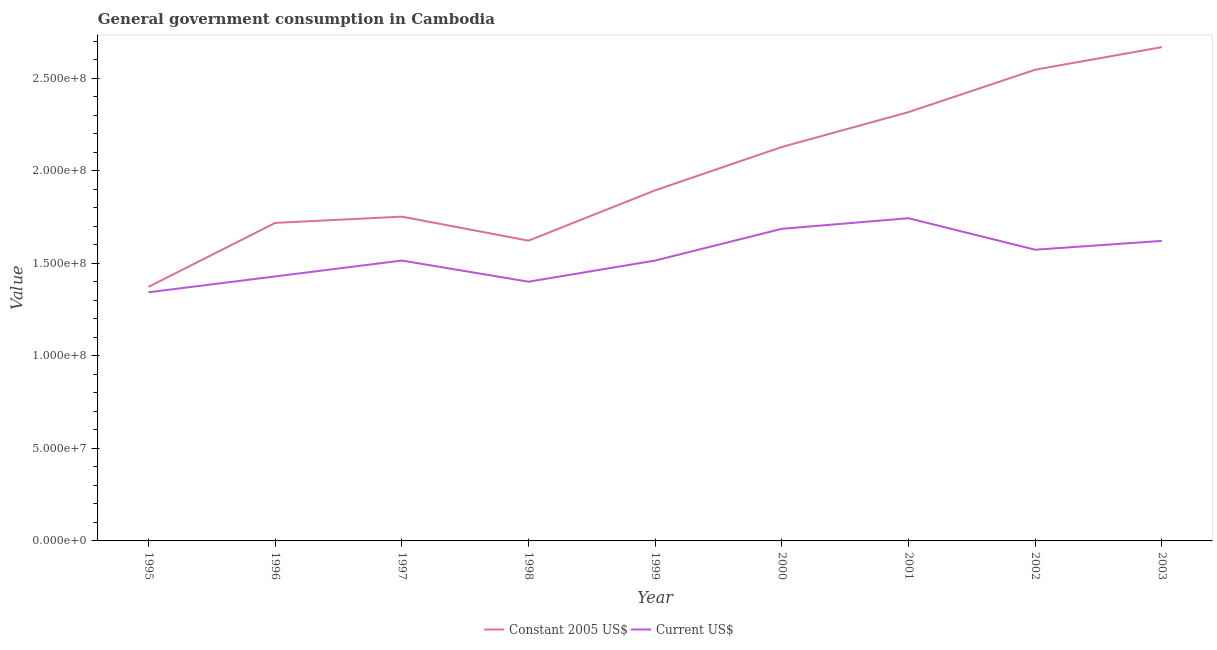Does the line corresponding to value consumed in current us$ intersect with the line corresponding to value consumed in constant 2005 us$?
Keep it short and to the point. No. Is the number of lines equal to the number of legend labels?
Your answer should be compact. Yes. What is the value consumed in current us$ in 2000?
Provide a short and direct response. 1.69e+08. Across all years, what is the maximum value consumed in current us$?
Give a very brief answer. 1.74e+08. Across all years, what is the minimum value consumed in current us$?
Offer a very short reply. 1.34e+08. What is the total value consumed in constant 2005 us$ in the graph?
Make the answer very short. 1.80e+09. What is the difference between the value consumed in current us$ in 2000 and that in 2003?
Make the answer very short. 6.53e+06. What is the difference between the value consumed in constant 2005 us$ in 1998 and the value consumed in current us$ in 2001?
Provide a succinct answer. -1.21e+07. What is the average value consumed in constant 2005 us$ per year?
Your response must be concise. 2.00e+08. In the year 1995, what is the difference between the value consumed in constant 2005 us$ and value consumed in current us$?
Offer a very short reply. 2.94e+06. In how many years, is the value consumed in current us$ greater than 250000000?
Your answer should be compact. 0. What is the ratio of the value consumed in constant 2005 us$ in 1996 to that in 2003?
Keep it short and to the point. 0.64. What is the difference between the highest and the second highest value consumed in constant 2005 us$?
Your answer should be compact. 1.22e+07. What is the difference between the highest and the lowest value consumed in constant 2005 us$?
Your answer should be compact. 1.29e+08. Is the value consumed in current us$ strictly greater than the value consumed in constant 2005 us$ over the years?
Offer a terse response. No. How many lines are there?
Provide a succinct answer. 2. How many years are there in the graph?
Ensure brevity in your answer.  9. Are the values on the major ticks of Y-axis written in scientific E-notation?
Ensure brevity in your answer.  Yes. Does the graph contain any zero values?
Keep it short and to the point. No. What is the title of the graph?
Offer a very short reply. General government consumption in Cambodia. What is the label or title of the Y-axis?
Make the answer very short. Value. What is the Value in Constant 2005 US$ in 1995?
Your answer should be compact. 1.37e+08. What is the Value in Current US$ in 1995?
Keep it short and to the point. 1.34e+08. What is the Value of Constant 2005 US$ in 1996?
Your response must be concise. 1.72e+08. What is the Value in Current US$ in 1996?
Your answer should be compact. 1.43e+08. What is the Value of Constant 2005 US$ in 1997?
Give a very brief answer. 1.75e+08. What is the Value of Current US$ in 1997?
Your response must be concise. 1.51e+08. What is the Value in Constant 2005 US$ in 1998?
Your response must be concise. 1.62e+08. What is the Value of Current US$ in 1998?
Ensure brevity in your answer.  1.40e+08. What is the Value in Constant 2005 US$ in 1999?
Offer a very short reply. 1.89e+08. What is the Value in Current US$ in 1999?
Ensure brevity in your answer.  1.51e+08. What is the Value of Constant 2005 US$ in 2000?
Offer a very short reply. 2.13e+08. What is the Value in Current US$ in 2000?
Offer a terse response. 1.69e+08. What is the Value of Constant 2005 US$ in 2001?
Your answer should be very brief. 2.32e+08. What is the Value in Current US$ in 2001?
Your answer should be compact. 1.74e+08. What is the Value in Constant 2005 US$ in 2002?
Make the answer very short. 2.54e+08. What is the Value of Current US$ in 2002?
Provide a short and direct response. 1.57e+08. What is the Value in Constant 2005 US$ in 2003?
Keep it short and to the point. 2.67e+08. What is the Value in Current US$ in 2003?
Your response must be concise. 1.62e+08. Across all years, what is the maximum Value of Constant 2005 US$?
Your answer should be very brief. 2.67e+08. Across all years, what is the maximum Value in Current US$?
Make the answer very short. 1.74e+08. Across all years, what is the minimum Value in Constant 2005 US$?
Offer a very short reply. 1.37e+08. Across all years, what is the minimum Value of Current US$?
Offer a very short reply. 1.34e+08. What is the total Value in Constant 2005 US$ in the graph?
Your answer should be compact. 1.80e+09. What is the total Value in Current US$ in the graph?
Offer a very short reply. 1.38e+09. What is the difference between the Value of Constant 2005 US$ in 1995 and that in 1996?
Your answer should be very brief. -3.45e+07. What is the difference between the Value of Current US$ in 1995 and that in 1996?
Your answer should be very brief. -8.57e+06. What is the difference between the Value in Constant 2005 US$ in 1995 and that in 1997?
Your answer should be very brief. -3.79e+07. What is the difference between the Value of Current US$ in 1995 and that in 1997?
Your answer should be very brief. -1.71e+07. What is the difference between the Value in Constant 2005 US$ in 1995 and that in 1998?
Make the answer very short. -2.50e+07. What is the difference between the Value of Current US$ in 1995 and that in 1998?
Your response must be concise. -5.71e+06. What is the difference between the Value of Constant 2005 US$ in 1995 and that in 1999?
Your response must be concise. -5.21e+07. What is the difference between the Value in Current US$ in 1995 and that in 1999?
Offer a very short reply. -1.71e+07. What is the difference between the Value of Constant 2005 US$ in 1995 and that in 2000?
Your answer should be very brief. -7.55e+07. What is the difference between the Value in Current US$ in 1995 and that in 2000?
Provide a succinct answer. -3.43e+07. What is the difference between the Value in Constant 2005 US$ in 1995 and that in 2001?
Provide a short and direct response. -9.44e+07. What is the difference between the Value in Current US$ in 1995 and that in 2001?
Offer a very short reply. -4.00e+07. What is the difference between the Value in Constant 2005 US$ in 1995 and that in 2002?
Your response must be concise. -1.17e+08. What is the difference between the Value in Current US$ in 1995 and that in 2002?
Offer a terse response. -2.30e+07. What is the difference between the Value of Constant 2005 US$ in 1995 and that in 2003?
Your answer should be compact. -1.29e+08. What is the difference between the Value in Current US$ in 1995 and that in 2003?
Your answer should be compact. -2.78e+07. What is the difference between the Value of Constant 2005 US$ in 1996 and that in 1997?
Keep it short and to the point. -3.38e+06. What is the difference between the Value in Current US$ in 1996 and that in 1997?
Your response must be concise. -8.57e+06. What is the difference between the Value of Constant 2005 US$ in 1996 and that in 1998?
Make the answer very short. 9.58e+06. What is the difference between the Value of Current US$ in 1996 and that in 1998?
Provide a short and direct response. 2.86e+06. What is the difference between the Value in Constant 2005 US$ in 1996 and that in 1999?
Provide a succinct answer. -1.76e+07. What is the difference between the Value in Current US$ in 1996 and that in 1999?
Give a very brief answer. -8.57e+06. What is the difference between the Value in Constant 2005 US$ in 1996 and that in 2000?
Offer a very short reply. -4.10e+07. What is the difference between the Value in Current US$ in 1996 and that in 2000?
Provide a short and direct response. -2.57e+07. What is the difference between the Value of Constant 2005 US$ in 1996 and that in 2001?
Offer a terse response. -5.98e+07. What is the difference between the Value of Current US$ in 1996 and that in 2001?
Your answer should be very brief. -3.14e+07. What is the difference between the Value of Constant 2005 US$ in 1996 and that in 2002?
Provide a succinct answer. -8.27e+07. What is the difference between the Value in Current US$ in 1996 and that in 2002?
Give a very brief answer. -1.44e+07. What is the difference between the Value in Constant 2005 US$ in 1996 and that in 2003?
Offer a very short reply. -9.49e+07. What is the difference between the Value in Current US$ in 1996 and that in 2003?
Make the answer very short. -1.92e+07. What is the difference between the Value of Constant 2005 US$ in 1997 and that in 1998?
Give a very brief answer. 1.30e+07. What is the difference between the Value in Current US$ in 1997 and that in 1998?
Ensure brevity in your answer.  1.14e+07. What is the difference between the Value in Constant 2005 US$ in 1997 and that in 1999?
Offer a very short reply. -1.42e+07. What is the difference between the Value in Constant 2005 US$ in 1997 and that in 2000?
Ensure brevity in your answer.  -3.76e+07. What is the difference between the Value of Current US$ in 1997 and that in 2000?
Your answer should be very brief. -1.71e+07. What is the difference between the Value in Constant 2005 US$ in 1997 and that in 2001?
Give a very brief answer. -5.64e+07. What is the difference between the Value of Current US$ in 1997 and that in 2001?
Offer a terse response. -2.29e+07. What is the difference between the Value in Constant 2005 US$ in 1997 and that in 2002?
Give a very brief answer. -7.93e+07. What is the difference between the Value in Current US$ in 1997 and that in 2002?
Offer a very short reply. -5.85e+06. What is the difference between the Value in Constant 2005 US$ in 1997 and that in 2003?
Your response must be concise. -9.15e+07. What is the difference between the Value in Current US$ in 1997 and that in 2003?
Provide a short and direct response. -1.06e+07. What is the difference between the Value in Constant 2005 US$ in 1998 and that in 1999?
Your answer should be compact. -2.72e+07. What is the difference between the Value of Current US$ in 1998 and that in 1999?
Your answer should be very brief. -1.14e+07. What is the difference between the Value in Constant 2005 US$ in 1998 and that in 2000?
Your response must be concise. -5.06e+07. What is the difference between the Value of Current US$ in 1998 and that in 2000?
Make the answer very short. -2.86e+07. What is the difference between the Value in Constant 2005 US$ in 1998 and that in 2001?
Your response must be concise. -6.94e+07. What is the difference between the Value in Current US$ in 1998 and that in 2001?
Your answer should be very brief. -3.43e+07. What is the difference between the Value in Constant 2005 US$ in 1998 and that in 2002?
Give a very brief answer. -9.23e+07. What is the difference between the Value of Current US$ in 1998 and that in 2002?
Provide a succinct answer. -1.73e+07. What is the difference between the Value in Constant 2005 US$ in 1998 and that in 2003?
Your answer should be very brief. -1.05e+08. What is the difference between the Value in Current US$ in 1998 and that in 2003?
Your answer should be very brief. -2.20e+07. What is the difference between the Value in Constant 2005 US$ in 1999 and that in 2000?
Keep it short and to the point. -2.34e+07. What is the difference between the Value in Current US$ in 1999 and that in 2000?
Your answer should be very brief. -1.71e+07. What is the difference between the Value of Constant 2005 US$ in 1999 and that in 2001?
Your response must be concise. -4.22e+07. What is the difference between the Value in Current US$ in 1999 and that in 2001?
Give a very brief answer. -2.29e+07. What is the difference between the Value of Constant 2005 US$ in 1999 and that in 2002?
Your answer should be compact. -6.51e+07. What is the difference between the Value of Current US$ in 1999 and that in 2002?
Ensure brevity in your answer.  -5.85e+06. What is the difference between the Value in Constant 2005 US$ in 1999 and that in 2003?
Give a very brief answer. -7.73e+07. What is the difference between the Value in Current US$ in 1999 and that in 2003?
Your response must be concise. -1.06e+07. What is the difference between the Value of Constant 2005 US$ in 2000 and that in 2001?
Offer a terse response. -1.88e+07. What is the difference between the Value in Current US$ in 2000 and that in 2001?
Your response must be concise. -5.71e+06. What is the difference between the Value in Constant 2005 US$ in 2000 and that in 2002?
Provide a succinct answer. -4.17e+07. What is the difference between the Value of Current US$ in 2000 and that in 2002?
Keep it short and to the point. 1.13e+07. What is the difference between the Value in Constant 2005 US$ in 2000 and that in 2003?
Give a very brief answer. -5.39e+07. What is the difference between the Value of Current US$ in 2000 and that in 2003?
Your answer should be very brief. 6.53e+06. What is the difference between the Value in Constant 2005 US$ in 2001 and that in 2002?
Provide a succinct answer. -2.29e+07. What is the difference between the Value in Current US$ in 2001 and that in 2002?
Give a very brief answer. 1.70e+07. What is the difference between the Value of Constant 2005 US$ in 2001 and that in 2003?
Give a very brief answer. -3.51e+07. What is the difference between the Value in Current US$ in 2001 and that in 2003?
Provide a succinct answer. 1.22e+07. What is the difference between the Value in Constant 2005 US$ in 2002 and that in 2003?
Keep it short and to the point. -1.22e+07. What is the difference between the Value in Current US$ in 2002 and that in 2003?
Make the answer very short. -4.77e+06. What is the difference between the Value in Constant 2005 US$ in 1995 and the Value in Current US$ in 1996?
Your response must be concise. -5.63e+06. What is the difference between the Value of Constant 2005 US$ in 1995 and the Value of Current US$ in 1997?
Your response must be concise. -1.42e+07. What is the difference between the Value of Constant 2005 US$ in 1995 and the Value of Current US$ in 1998?
Offer a terse response. -2.77e+06. What is the difference between the Value of Constant 2005 US$ in 1995 and the Value of Current US$ in 1999?
Ensure brevity in your answer.  -1.42e+07. What is the difference between the Value of Constant 2005 US$ in 1995 and the Value of Current US$ in 2000?
Your answer should be compact. -3.13e+07. What is the difference between the Value in Constant 2005 US$ in 1995 and the Value in Current US$ in 2001?
Give a very brief answer. -3.71e+07. What is the difference between the Value of Constant 2005 US$ in 1995 and the Value of Current US$ in 2002?
Your answer should be very brief. -2.00e+07. What is the difference between the Value in Constant 2005 US$ in 1995 and the Value in Current US$ in 2003?
Your answer should be very brief. -2.48e+07. What is the difference between the Value of Constant 2005 US$ in 1996 and the Value of Current US$ in 1997?
Your answer should be very brief. 2.03e+07. What is the difference between the Value in Constant 2005 US$ in 1996 and the Value in Current US$ in 1998?
Give a very brief answer. 3.18e+07. What is the difference between the Value in Constant 2005 US$ in 1996 and the Value in Current US$ in 1999?
Make the answer very short. 2.03e+07. What is the difference between the Value in Constant 2005 US$ in 1996 and the Value in Current US$ in 2000?
Offer a very short reply. 3.19e+06. What is the difference between the Value in Constant 2005 US$ in 1996 and the Value in Current US$ in 2001?
Offer a very short reply. -2.53e+06. What is the difference between the Value of Constant 2005 US$ in 1996 and the Value of Current US$ in 2002?
Give a very brief answer. 1.45e+07. What is the difference between the Value in Constant 2005 US$ in 1996 and the Value in Current US$ in 2003?
Give a very brief answer. 9.71e+06. What is the difference between the Value of Constant 2005 US$ in 1997 and the Value of Current US$ in 1998?
Keep it short and to the point. 3.51e+07. What is the difference between the Value in Constant 2005 US$ in 1997 and the Value in Current US$ in 1999?
Your answer should be very brief. 2.37e+07. What is the difference between the Value of Constant 2005 US$ in 1997 and the Value of Current US$ in 2000?
Your answer should be very brief. 6.57e+06. What is the difference between the Value in Constant 2005 US$ in 1997 and the Value in Current US$ in 2001?
Keep it short and to the point. 8.58e+05. What is the difference between the Value in Constant 2005 US$ in 1997 and the Value in Current US$ in 2002?
Offer a terse response. 1.79e+07. What is the difference between the Value of Constant 2005 US$ in 1997 and the Value of Current US$ in 2003?
Your answer should be very brief. 1.31e+07. What is the difference between the Value in Constant 2005 US$ in 1998 and the Value in Current US$ in 1999?
Make the answer very short. 1.07e+07. What is the difference between the Value in Constant 2005 US$ in 1998 and the Value in Current US$ in 2000?
Your response must be concise. -6.39e+06. What is the difference between the Value of Constant 2005 US$ in 1998 and the Value of Current US$ in 2001?
Your answer should be very brief. -1.21e+07. What is the difference between the Value of Constant 2005 US$ in 1998 and the Value of Current US$ in 2002?
Ensure brevity in your answer.  4.90e+06. What is the difference between the Value of Constant 2005 US$ in 1998 and the Value of Current US$ in 2003?
Your answer should be compact. 1.33e+05. What is the difference between the Value in Constant 2005 US$ in 1999 and the Value in Current US$ in 2000?
Give a very brief answer. 2.08e+07. What is the difference between the Value of Constant 2005 US$ in 1999 and the Value of Current US$ in 2001?
Your answer should be very brief. 1.51e+07. What is the difference between the Value of Constant 2005 US$ in 1999 and the Value of Current US$ in 2002?
Your answer should be very brief. 3.21e+07. What is the difference between the Value in Constant 2005 US$ in 1999 and the Value in Current US$ in 2003?
Offer a terse response. 2.73e+07. What is the difference between the Value in Constant 2005 US$ in 2000 and the Value in Current US$ in 2001?
Your answer should be compact. 3.85e+07. What is the difference between the Value of Constant 2005 US$ in 2000 and the Value of Current US$ in 2002?
Provide a short and direct response. 5.55e+07. What is the difference between the Value in Constant 2005 US$ in 2000 and the Value in Current US$ in 2003?
Offer a very short reply. 5.07e+07. What is the difference between the Value of Constant 2005 US$ in 2001 and the Value of Current US$ in 2002?
Your answer should be very brief. 7.43e+07. What is the difference between the Value in Constant 2005 US$ in 2001 and the Value in Current US$ in 2003?
Offer a very short reply. 6.95e+07. What is the difference between the Value of Constant 2005 US$ in 2002 and the Value of Current US$ in 2003?
Give a very brief answer. 9.24e+07. What is the average Value of Constant 2005 US$ per year?
Your response must be concise. 2.00e+08. What is the average Value in Current US$ per year?
Your answer should be compact. 1.54e+08. In the year 1995, what is the difference between the Value in Constant 2005 US$ and Value in Current US$?
Keep it short and to the point. 2.94e+06. In the year 1996, what is the difference between the Value of Constant 2005 US$ and Value of Current US$?
Your answer should be very brief. 2.89e+07. In the year 1997, what is the difference between the Value of Constant 2005 US$ and Value of Current US$?
Offer a very short reply. 2.37e+07. In the year 1998, what is the difference between the Value of Constant 2005 US$ and Value of Current US$?
Keep it short and to the point. 2.22e+07. In the year 1999, what is the difference between the Value of Constant 2005 US$ and Value of Current US$?
Your response must be concise. 3.79e+07. In the year 2000, what is the difference between the Value of Constant 2005 US$ and Value of Current US$?
Keep it short and to the point. 4.42e+07. In the year 2001, what is the difference between the Value of Constant 2005 US$ and Value of Current US$?
Make the answer very short. 5.73e+07. In the year 2002, what is the difference between the Value in Constant 2005 US$ and Value in Current US$?
Your answer should be compact. 9.72e+07. In the year 2003, what is the difference between the Value of Constant 2005 US$ and Value of Current US$?
Make the answer very short. 1.05e+08. What is the ratio of the Value in Constant 2005 US$ in 1995 to that in 1996?
Offer a terse response. 0.8. What is the ratio of the Value in Current US$ in 1995 to that in 1996?
Offer a terse response. 0.94. What is the ratio of the Value of Constant 2005 US$ in 1995 to that in 1997?
Provide a succinct answer. 0.78. What is the ratio of the Value in Current US$ in 1995 to that in 1997?
Offer a terse response. 0.89. What is the ratio of the Value of Constant 2005 US$ in 1995 to that in 1998?
Offer a terse response. 0.85. What is the ratio of the Value of Current US$ in 1995 to that in 1998?
Offer a terse response. 0.96. What is the ratio of the Value in Constant 2005 US$ in 1995 to that in 1999?
Your answer should be compact. 0.72. What is the ratio of the Value of Current US$ in 1995 to that in 1999?
Give a very brief answer. 0.89. What is the ratio of the Value in Constant 2005 US$ in 1995 to that in 2000?
Ensure brevity in your answer.  0.65. What is the ratio of the Value of Current US$ in 1995 to that in 2000?
Make the answer very short. 0.8. What is the ratio of the Value of Constant 2005 US$ in 1995 to that in 2001?
Offer a very short reply. 0.59. What is the ratio of the Value in Current US$ in 1995 to that in 2001?
Provide a short and direct response. 0.77. What is the ratio of the Value in Constant 2005 US$ in 1995 to that in 2002?
Give a very brief answer. 0.54. What is the ratio of the Value of Current US$ in 1995 to that in 2002?
Give a very brief answer. 0.85. What is the ratio of the Value of Constant 2005 US$ in 1995 to that in 2003?
Give a very brief answer. 0.51. What is the ratio of the Value in Current US$ in 1995 to that in 2003?
Your response must be concise. 0.83. What is the ratio of the Value of Constant 2005 US$ in 1996 to that in 1997?
Make the answer very short. 0.98. What is the ratio of the Value of Current US$ in 1996 to that in 1997?
Provide a short and direct response. 0.94. What is the ratio of the Value in Constant 2005 US$ in 1996 to that in 1998?
Give a very brief answer. 1.06. What is the ratio of the Value in Current US$ in 1996 to that in 1998?
Provide a short and direct response. 1.02. What is the ratio of the Value in Constant 2005 US$ in 1996 to that in 1999?
Your response must be concise. 0.91. What is the ratio of the Value in Current US$ in 1996 to that in 1999?
Your response must be concise. 0.94. What is the ratio of the Value in Constant 2005 US$ in 1996 to that in 2000?
Your response must be concise. 0.81. What is the ratio of the Value of Current US$ in 1996 to that in 2000?
Provide a succinct answer. 0.85. What is the ratio of the Value in Constant 2005 US$ in 1996 to that in 2001?
Your response must be concise. 0.74. What is the ratio of the Value of Current US$ in 1996 to that in 2001?
Your answer should be very brief. 0.82. What is the ratio of the Value in Constant 2005 US$ in 1996 to that in 2002?
Offer a terse response. 0.67. What is the ratio of the Value of Current US$ in 1996 to that in 2002?
Offer a terse response. 0.91. What is the ratio of the Value in Constant 2005 US$ in 1996 to that in 2003?
Provide a short and direct response. 0.64. What is the ratio of the Value of Current US$ in 1996 to that in 2003?
Make the answer very short. 0.88. What is the ratio of the Value of Constant 2005 US$ in 1997 to that in 1998?
Provide a short and direct response. 1.08. What is the ratio of the Value of Current US$ in 1997 to that in 1998?
Give a very brief answer. 1.08. What is the ratio of the Value in Constant 2005 US$ in 1997 to that in 1999?
Offer a very short reply. 0.92. What is the ratio of the Value in Constant 2005 US$ in 1997 to that in 2000?
Keep it short and to the point. 0.82. What is the ratio of the Value of Current US$ in 1997 to that in 2000?
Your answer should be very brief. 0.9. What is the ratio of the Value in Constant 2005 US$ in 1997 to that in 2001?
Your answer should be very brief. 0.76. What is the ratio of the Value of Current US$ in 1997 to that in 2001?
Offer a terse response. 0.87. What is the ratio of the Value in Constant 2005 US$ in 1997 to that in 2002?
Ensure brevity in your answer.  0.69. What is the ratio of the Value of Current US$ in 1997 to that in 2002?
Give a very brief answer. 0.96. What is the ratio of the Value of Constant 2005 US$ in 1997 to that in 2003?
Offer a very short reply. 0.66. What is the ratio of the Value in Current US$ in 1997 to that in 2003?
Make the answer very short. 0.93. What is the ratio of the Value in Constant 2005 US$ in 1998 to that in 1999?
Provide a short and direct response. 0.86. What is the ratio of the Value of Current US$ in 1998 to that in 1999?
Your response must be concise. 0.92. What is the ratio of the Value of Constant 2005 US$ in 1998 to that in 2000?
Provide a succinct answer. 0.76. What is the ratio of the Value of Current US$ in 1998 to that in 2000?
Offer a very short reply. 0.83. What is the ratio of the Value in Constant 2005 US$ in 1998 to that in 2001?
Ensure brevity in your answer.  0.7. What is the ratio of the Value of Current US$ in 1998 to that in 2001?
Give a very brief answer. 0.8. What is the ratio of the Value of Constant 2005 US$ in 1998 to that in 2002?
Make the answer very short. 0.64. What is the ratio of the Value of Current US$ in 1998 to that in 2002?
Provide a short and direct response. 0.89. What is the ratio of the Value of Constant 2005 US$ in 1998 to that in 2003?
Provide a short and direct response. 0.61. What is the ratio of the Value in Current US$ in 1998 to that in 2003?
Offer a very short reply. 0.86. What is the ratio of the Value in Constant 2005 US$ in 1999 to that in 2000?
Provide a short and direct response. 0.89. What is the ratio of the Value of Current US$ in 1999 to that in 2000?
Give a very brief answer. 0.9. What is the ratio of the Value of Constant 2005 US$ in 1999 to that in 2001?
Offer a very short reply. 0.82. What is the ratio of the Value in Current US$ in 1999 to that in 2001?
Give a very brief answer. 0.87. What is the ratio of the Value of Constant 2005 US$ in 1999 to that in 2002?
Offer a very short reply. 0.74. What is the ratio of the Value of Current US$ in 1999 to that in 2002?
Make the answer very short. 0.96. What is the ratio of the Value of Constant 2005 US$ in 1999 to that in 2003?
Your answer should be compact. 0.71. What is the ratio of the Value in Current US$ in 1999 to that in 2003?
Your answer should be compact. 0.93. What is the ratio of the Value in Constant 2005 US$ in 2000 to that in 2001?
Provide a succinct answer. 0.92. What is the ratio of the Value of Current US$ in 2000 to that in 2001?
Your answer should be compact. 0.97. What is the ratio of the Value in Constant 2005 US$ in 2000 to that in 2002?
Ensure brevity in your answer.  0.84. What is the ratio of the Value in Current US$ in 2000 to that in 2002?
Make the answer very short. 1.07. What is the ratio of the Value of Constant 2005 US$ in 2000 to that in 2003?
Provide a succinct answer. 0.8. What is the ratio of the Value in Current US$ in 2000 to that in 2003?
Your answer should be very brief. 1.04. What is the ratio of the Value of Constant 2005 US$ in 2001 to that in 2002?
Your answer should be compact. 0.91. What is the ratio of the Value of Current US$ in 2001 to that in 2002?
Your answer should be very brief. 1.11. What is the ratio of the Value of Constant 2005 US$ in 2001 to that in 2003?
Offer a terse response. 0.87. What is the ratio of the Value of Current US$ in 2001 to that in 2003?
Give a very brief answer. 1.08. What is the ratio of the Value in Constant 2005 US$ in 2002 to that in 2003?
Your answer should be very brief. 0.95. What is the ratio of the Value in Current US$ in 2002 to that in 2003?
Ensure brevity in your answer.  0.97. What is the difference between the highest and the second highest Value of Constant 2005 US$?
Offer a terse response. 1.22e+07. What is the difference between the highest and the second highest Value in Current US$?
Offer a very short reply. 5.71e+06. What is the difference between the highest and the lowest Value of Constant 2005 US$?
Provide a succinct answer. 1.29e+08. What is the difference between the highest and the lowest Value of Current US$?
Ensure brevity in your answer.  4.00e+07. 